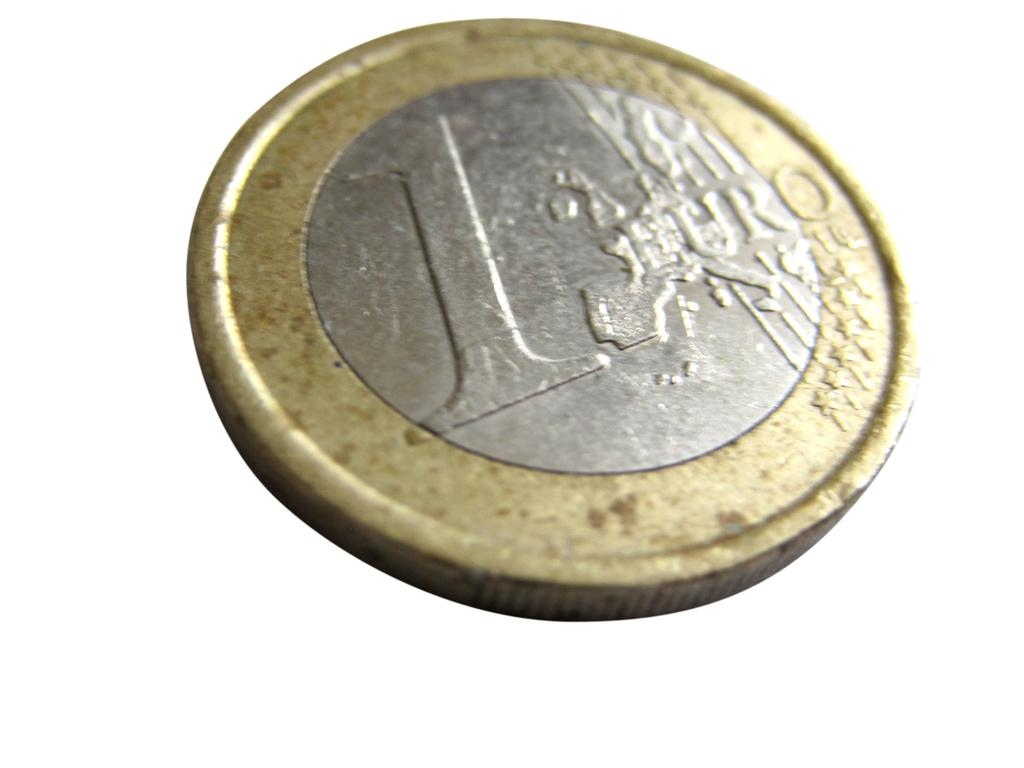<image>
Render a clear and concise summary of the photo. Gold and silver coin for 1 Euro in a white background. 